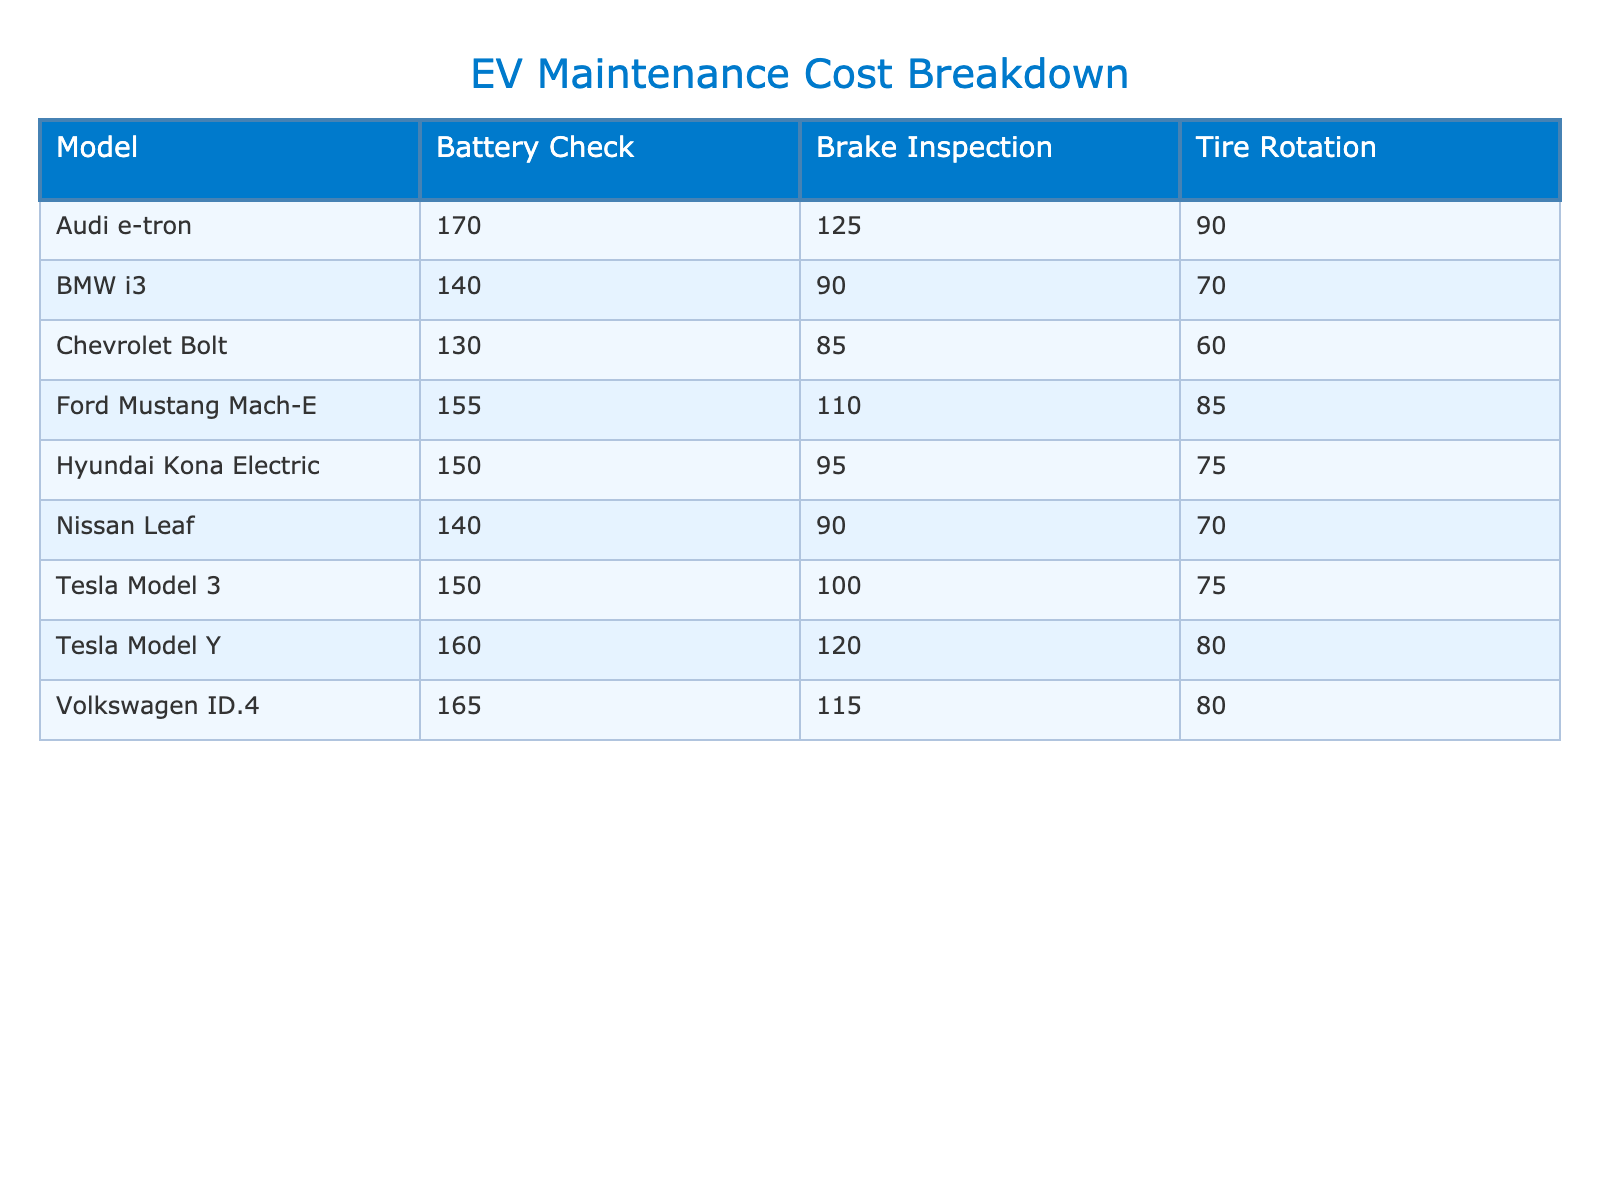What is the maintenance cost for a Battery Check on a Tesla Model 3? The table shows the maintenance cost for a Battery Check specifically for the Tesla Model 3 is listed as 150 USD.
Answer: 150 USD Which model has the highest cost for Tire Rotation? By reviewing the Tire Rotation costs in the table, the Audi e-tron has the highest maintenance cost of 90 USD for this service.
Answer: Audi e-tron Calculate the total maintenance cost for Battery Checks across all models. The Battery Check costs for each model are: 150 (Tesla Model 3) + 160 (Tesla Model Y) + 140 (Nissan Leaf) + 130 (Chevrolet Bolt) + 155 (Ford Mustang Mach-E) + 150 (Hyundai Kona Electric) + 140 (BMW i3) + 165 (Volkswagen ID.4) + 170 (Audi e-tron) = 1,320 USD.
Answer: 1,320 USD Is the maintenance cost for Brake Inspection on a Chevrolet Bolt less than 90 USD? The table indicates that the Brake Inspection cost for a Chevrolet Bolt is 85 USD, which is indeed less than 90 USD.
Answer: Yes What is the average maintenance cost for Tire Rotation across all models? The Tire Rotation costs are: 75 (Tesla Model 3) + 80 (Tesla Model Y) + 70 (Nissan Leaf) + 60 (Chevrolet Bolt) + 85 (Ford Mustang Mach-E) + 75 (Hyundai Kona Electric) + 70 (BMW i3) + 80 (Volkswagen ID.4) + 90 (Audi e-tron) = 685 USD. There are 9 models, so the average is 685/9 ≈ 76.11 USD.
Answer: 76.11 USD Which model has the lowest total maintenance cost if we sum all service types? To find the model with the lowest total maintenance cost, we calculate the total for each: Tesla Model 3: 75 + 150 + 100 = 325 USD; Tesla Model Y: 80 + 160 + 120 = 360 USD; Nissan Leaf: 70 + 140 + 90 = 300 USD; Chevrolet Bolt: 60 + 130 + 85 = 275 USD; Ford Mustang Mach-E: 85 + 155 + 110 = 350 USD; Hyundai Kona Electric: 75 + 150 + 95 = 320 USD; BMW i3: 70 + 140 + 90 = 300 USD; Volkswagen ID.4: 80 + 165 + 115 = 360 USD; Audi e-tron: 90 + 170 + 125 = 385 USD. The Chevrolet Bolt has the lowest total with 275 USD.
Answer: Chevrolet Bolt Do all models have a maintenance cost for all service types? By examining the table, each model listed has corresponding costs for all three service types (Tire Rotation, Battery Check, Brake Inspection), so the answer is yes.
Answer: Yes What is the difference in maintenance cost for Battery Checks between the Tesla Model Y and Ford Mustang Mach-E? The Battery Check cost for Tesla Model Y is 160 USD and for Ford Mustang Mach-E is 155 USD. The difference is 160 - 155 = 5 USD.
Answer: 5 USD Which service type is the most expensive for the Volkswagen ID.4? From the table, the Battery Check is the most expensive service for the Volkswagen ID.4, costing 165 USD.
Answer: Battery Check 